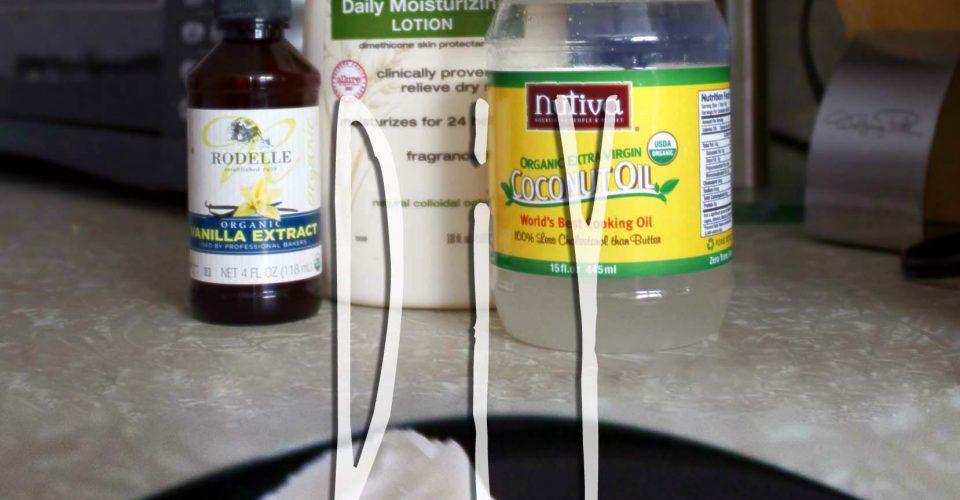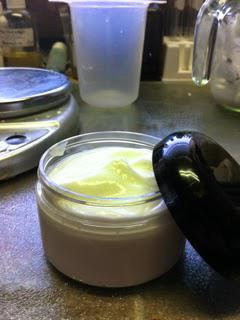The first image is the image on the left, the second image is the image on the right. Analyze the images presented: Is the assertion "At least one image has exactly three containers." valid? Answer yes or no. Yes. The first image is the image on the left, the second image is the image on the right. Given the left and right images, does the statement "There are many bathroom items, and not just makeup and lotion." hold true? Answer yes or no. No. 